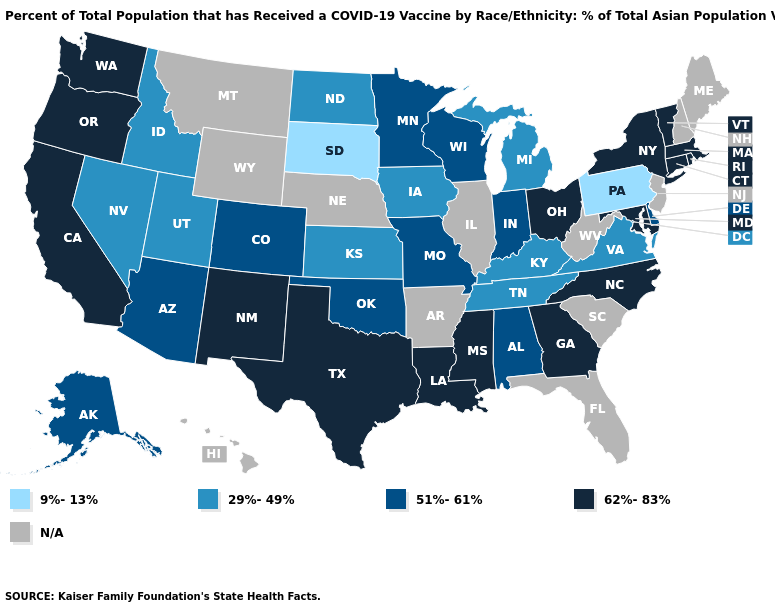What is the value of New Hampshire?
Be succinct. N/A. Name the states that have a value in the range N/A?
Concise answer only. Arkansas, Florida, Hawaii, Illinois, Maine, Montana, Nebraska, New Hampshire, New Jersey, South Carolina, West Virginia, Wyoming. What is the highest value in the USA?
Be succinct. 62%-83%. Name the states that have a value in the range 51%-61%?
Concise answer only. Alabama, Alaska, Arizona, Colorado, Delaware, Indiana, Minnesota, Missouri, Oklahoma, Wisconsin. What is the lowest value in states that border Tennessee?
Short answer required. 29%-49%. Name the states that have a value in the range N/A?
Short answer required. Arkansas, Florida, Hawaii, Illinois, Maine, Montana, Nebraska, New Hampshire, New Jersey, South Carolina, West Virginia, Wyoming. Does the first symbol in the legend represent the smallest category?
Write a very short answer. Yes. Does South Dakota have the lowest value in the USA?
Keep it brief. Yes. Which states have the lowest value in the USA?
Keep it brief. Pennsylvania, South Dakota. What is the highest value in the South ?
Quick response, please. 62%-83%. Does South Dakota have the lowest value in the MidWest?
Give a very brief answer. Yes. Does Connecticut have the highest value in the USA?
Concise answer only. Yes. Is the legend a continuous bar?
Quick response, please. No. 